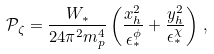<formula> <loc_0><loc_0><loc_500><loc_500>\mathcal { P } _ { \zeta } = \frac { W _ { * } } { 2 4 \pi ^ { 2 } m _ { p } ^ { 4 } } \left ( \frac { x _ { h } ^ { 2 } } { \epsilon _ { * } ^ { \phi } } + \frac { y _ { h } ^ { 2 } } { \epsilon _ { * } ^ { \chi } } \right ) \, ,</formula> 